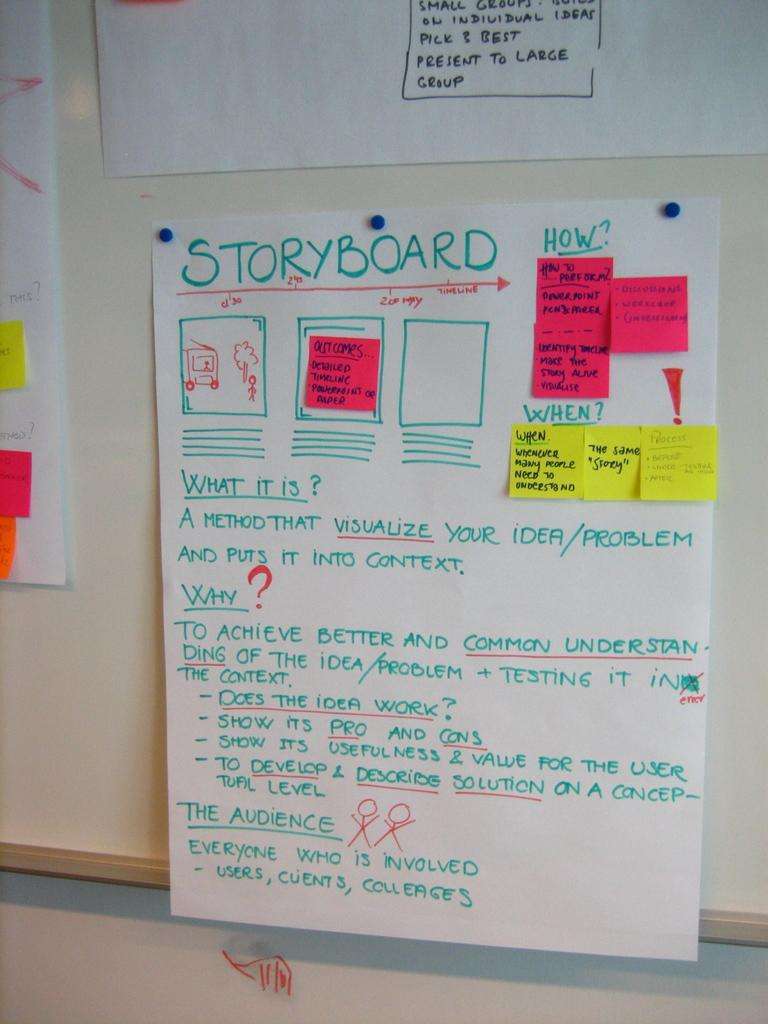<image>
Share a concise interpretation of the image provided. Board with a white sign that says "Storyboard" on top. 